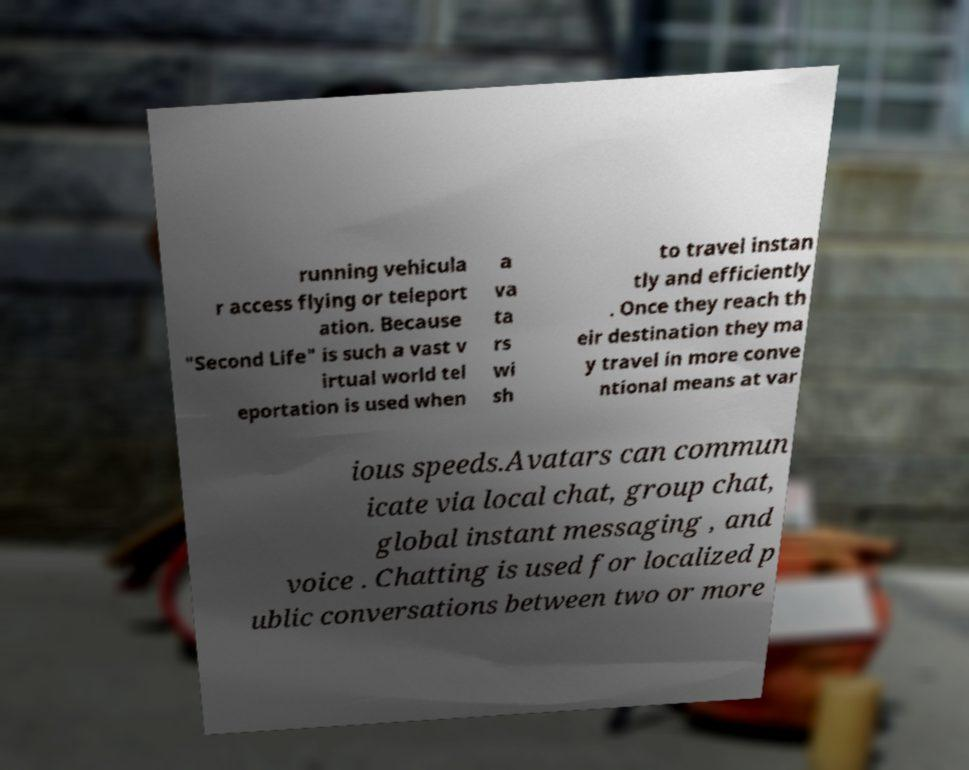There's text embedded in this image that I need extracted. Can you transcribe it verbatim? running vehicula r access flying or teleport ation. Because "Second Life" is such a vast v irtual world tel eportation is used when a va ta rs wi sh to travel instan tly and efficiently . Once they reach th eir destination they ma y travel in more conve ntional means at var ious speeds.Avatars can commun icate via local chat, group chat, global instant messaging , and voice . Chatting is used for localized p ublic conversations between two or more 